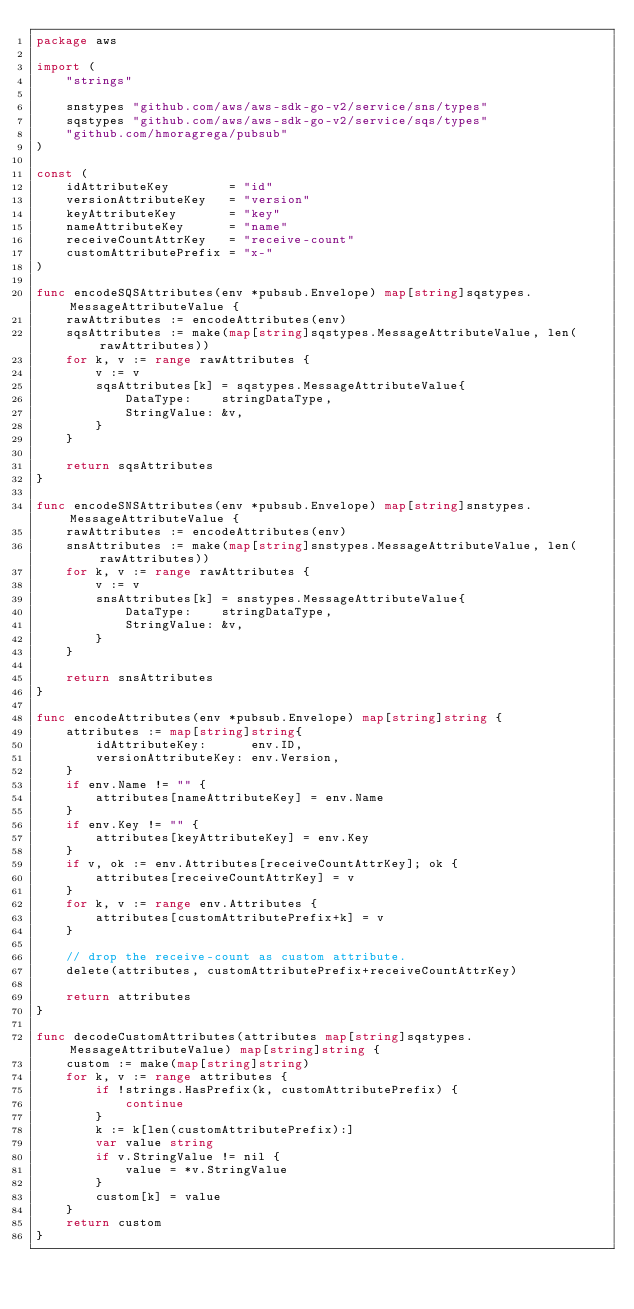<code> <loc_0><loc_0><loc_500><loc_500><_Go_>package aws

import (
	"strings"

	snstypes "github.com/aws/aws-sdk-go-v2/service/sns/types"
	sqstypes "github.com/aws/aws-sdk-go-v2/service/sqs/types"
	"github.com/hmoragrega/pubsub"
)

const (
	idAttributeKey        = "id"
	versionAttributeKey   = "version"
	keyAttributeKey       = "key"
	nameAttributeKey      = "name"
	receiveCountAttrKey   = "receive-count"
	customAttributePrefix = "x-"
)

func encodeSQSAttributes(env *pubsub.Envelope) map[string]sqstypes.MessageAttributeValue {
	rawAttributes := encodeAttributes(env)
	sqsAttributes := make(map[string]sqstypes.MessageAttributeValue, len(rawAttributes))
	for k, v := range rawAttributes {
		v := v
		sqsAttributes[k] = sqstypes.MessageAttributeValue{
			DataType:    stringDataType,
			StringValue: &v,
		}
	}

	return sqsAttributes
}

func encodeSNSAttributes(env *pubsub.Envelope) map[string]snstypes.MessageAttributeValue {
	rawAttributes := encodeAttributes(env)
	snsAttributes := make(map[string]snstypes.MessageAttributeValue, len(rawAttributes))
	for k, v := range rawAttributes {
		v := v
		snsAttributes[k] = snstypes.MessageAttributeValue{
			DataType:    stringDataType,
			StringValue: &v,
		}
	}

	return snsAttributes
}

func encodeAttributes(env *pubsub.Envelope) map[string]string {
	attributes := map[string]string{
		idAttributeKey:      env.ID,
		versionAttributeKey: env.Version,
	}
	if env.Name != "" {
		attributes[nameAttributeKey] = env.Name
	}
	if env.Key != "" {
		attributes[keyAttributeKey] = env.Key
	}
	if v, ok := env.Attributes[receiveCountAttrKey]; ok {
		attributes[receiveCountAttrKey] = v
	}
	for k, v := range env.Attributes {
		attributes[customAttributePrefix+k] = v
	}

	// drop the receive-count as custom attribute.
	delete(attributes, customAttributePrefix+receiveCountAttrKey)

	return attributes
}

func decodeCustomAttributes(attributes map[string]sqstypes.MessageAttributeValue) map[string]string {
	custom := make(map[string]string)
	for k, v := range attributes {
		if !strings.HasPrefix(k, customAttributePrefix) {
			continue
		}
		k := k[len(customAttributePrefix):]
		var value string
		if v.StringValue != nil {
			value = *v.StringValue
		}
		custom[k] = value
	}
	return custom
}
</code> 